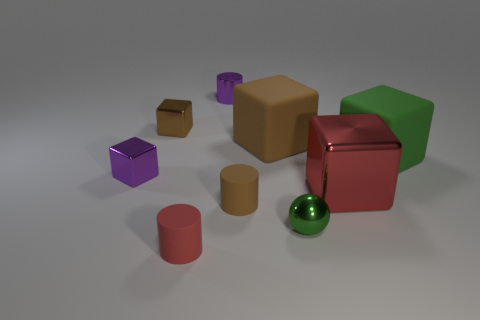How many small brown matte things have the same shape as the small red matte thing?
Your response must be concise. 1. What is the shape of the tiny thing that is the same color as the big metallic block?
Keep it short and to the point. Cylinder. There is a big brown matte thing; are there any purple things behind it?
Your answer should be very brief. Yes. Is the large green object the same shape as the large metallic object?
Your response must be concise. Yes. There is a red object that is on the right side of the small purple thing that is behind the tiny cube that is in front of the green matte block; what size is it?
Give a very brief answer. Large. What material is the green cube?
Make the answer very short. Rubber. What size is the thing that is the same color as the small shiny sphere?
Offer a very short reply. Large. Does the big red object have the same shape as the tiny purple thing that is in front of the tiny purple metallic cylinder?
Keep it short and to the point. Yes. There is a green object behind the brown matte cylinder on the left side of the matte thing right of the tiny sphere; what is its material?
Give a very brief answer. Rubber. How many large metallic cubes are there?
Provide a succinct answer. 1. 